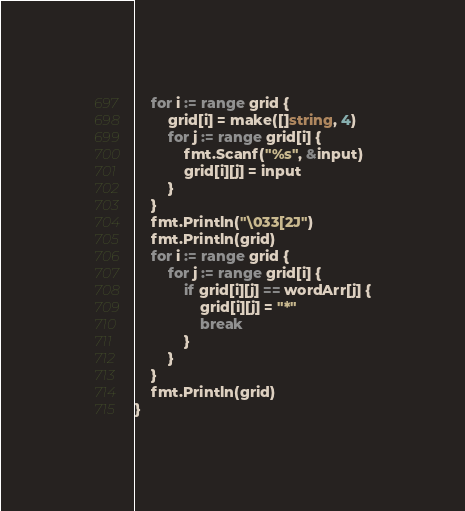<code> <loc_0><loc_0><loc_500><loc_500><_Go_>	for i := range grid {
		grid[i] = make([]string, 4)
		for j := range grid[i] {
			fmt.Scanf("%s", &input)
			grid[i][j] = input
		}
	}
	fmt.Println("\033[2J")
	fmt.Println(grid)
	for i := range grid {
		for j := range grid[i] {
			if grid[i][j] == wordArr[j] {
				grid[i][j] = "*"
				break
			}
		}
	}
	fmt.Println(grid)
}
</code> 